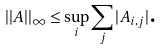<formula> <loc_0><loc_0><loc_500><loc_500>| | A | | _ { \infty } \leq \sup _ { i } \sum _ { j } | A _ { i , j } | { \text {.} }</formula> 